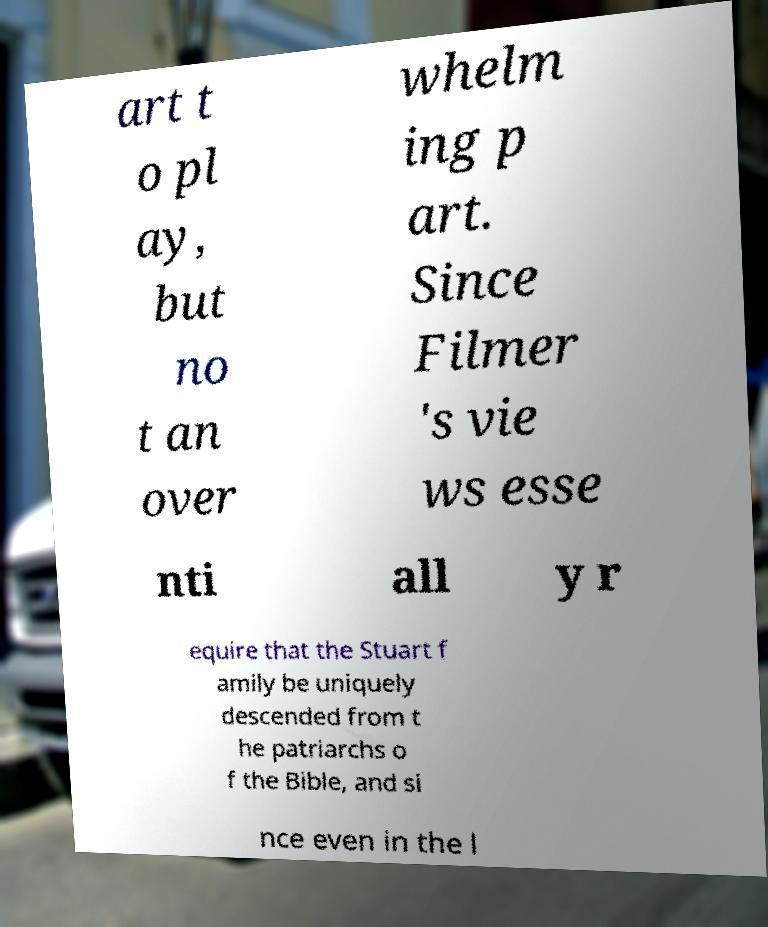Can you read and provide the text displayed in the image?This photo seems to have some interesting text. Can you extract and type it out for me? art t o pl ay, but no t an over whelm ing p art. Since Filmer 's vie ws esse nti all y r equire that the Stuart f amily be uniquely descended from t he patriarchs o f the Bible, and si nce even in the l 